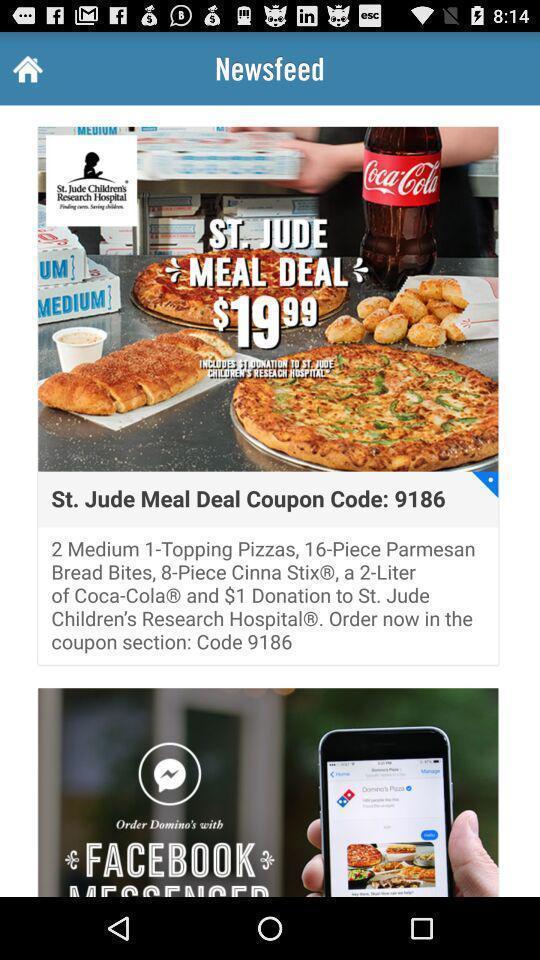Give me a summary of this screen capture. Page shows the meal deal details on food app. 